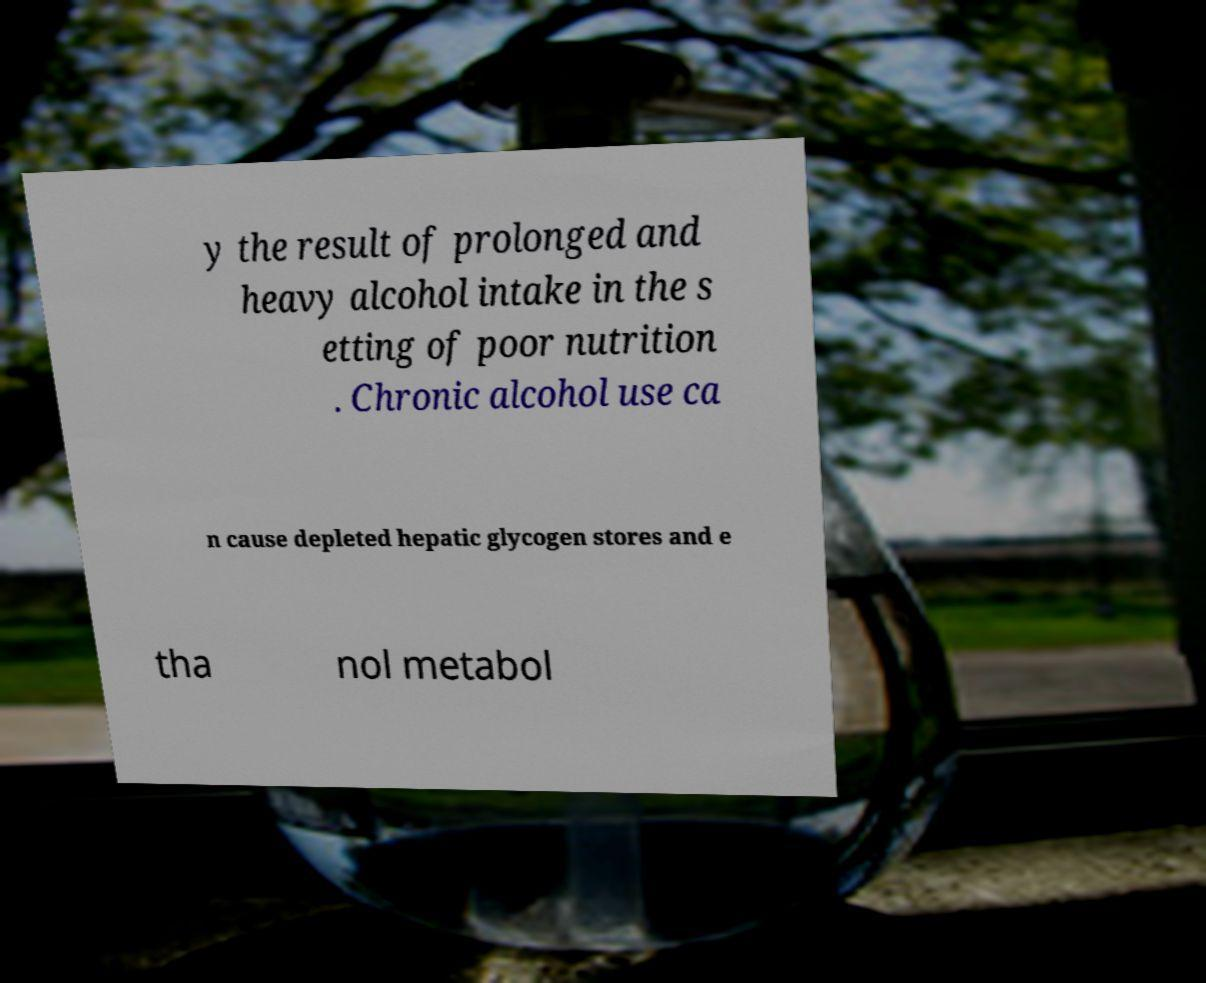Please read and relay the text visible in this image. What does it say? y the result of prolonged and heavy alcohol intake in the s etting of poor nutrition . Chronic alcohol use ca n cause depleted hepatic glycogen stores and e tha nol metabol 